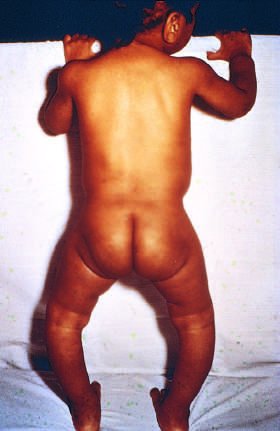what is bowing of legs the consequence of?
Answer the question using a single word or phrase. The formation of poorly mineralized bone in a child 